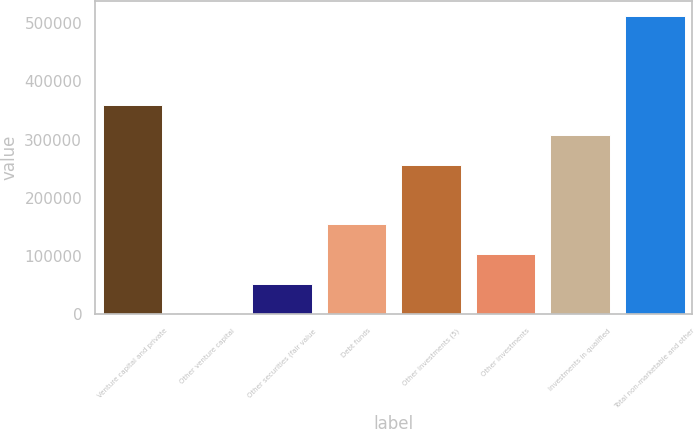Convert chart. <chart><loc_0><loc_0><loc_500><loc_500><bar_chart><fcel>Venture capital and private<fcel>Other venture capital<fcel>Other securities (fair value<fcel>Debt funds<fcel>Other investments (5)<fcel>Other investments<fcel>Investments in qualified<fcel>Total non-marketable and other<nl><fcel>358804<fcel>1823<fcel>52820.3<fcel>154815<fcel>256810<fcel>103818<fcel>307807<fcel>511796<nl></chart> 